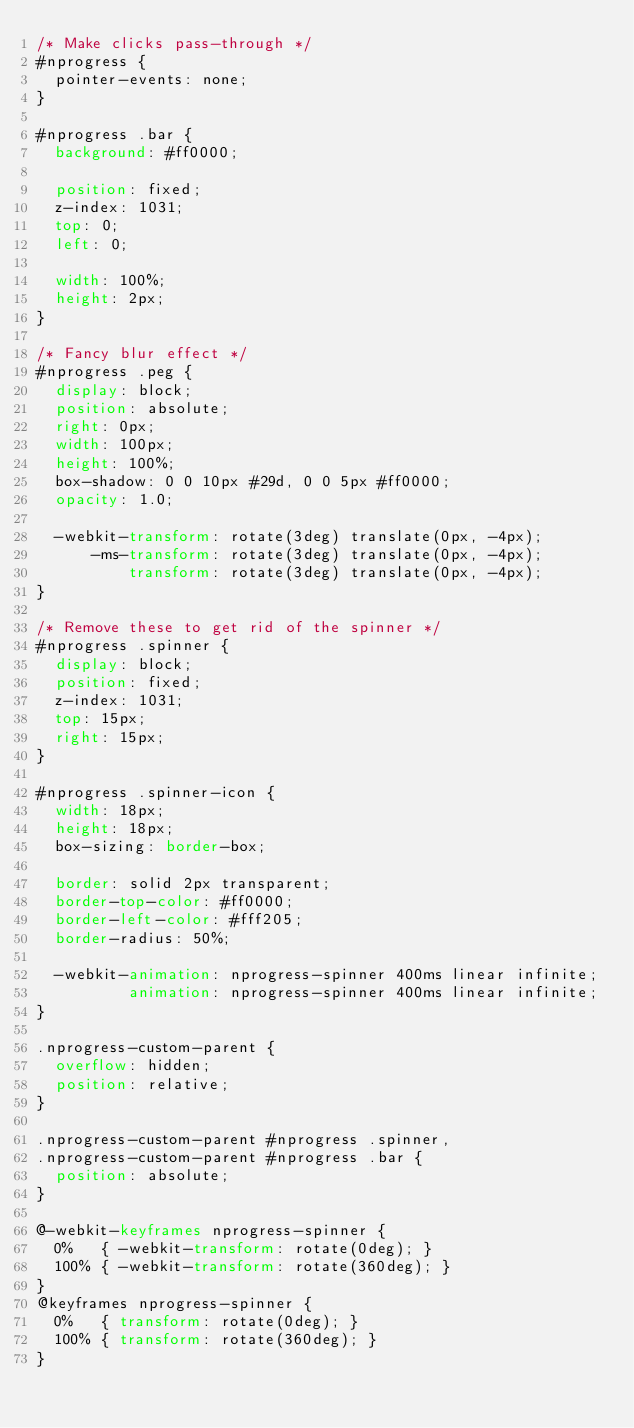Convert code to text. <code><loc_0><loc_0><loc_500><loc_500><_CSS_>/* Make clicks pass-through */
#nprogress {
  pointer-events: none;
}

#nprogress .bar {
  background: #ff0000;

  position: fixed;
  z-index: 1031;
  top: 0;
  left: 0;

  width: 100%;
  height: 2px;
}

/* Fancy blur effect */
#nprogress .peg {
  display: block;
  position: absolute;
  right: 0px;
  width: 100px;
  height: 100%;
  box-shadow: 0 0 10px #29d, 0 0 5px #ff0000;
  opacity: 1.0;

  -webkit-transform: rotate(3deg) translate(0px, -4px);
      -ms-transform: rotate(3deg) translate(0px, -4px);
          transform: rotate(3deg) translate(0px, -4px);
}

/* Remove these to get rid of the spinner */
#nprogress .spinner {
  display: block;
  position: fixed;
  z-index: 1031;
  top: 15px;
  right: 15px;
}

#nprogress .spinner-icon {
  width: 18px;
  height: 18px;
  box-sizing: border-box;

  border: solid 2px transparent;
  border-top-color: #ff0000;
  border-left-color: #fff205;
  border-radius: 50%;

  -webkit-animation: nprogress-spinner 400ms linear infinite;
          animation: nprogress-spinner 400ms linear infinite;
}

.nprogress-custom-parent {
  overflow: hidden;
  position: relative;
}

.nprogress-custom-parent #nprogress .spinner,
.nprogress-custom-parent #nprogress .bar {
  position: absolute;
}

@-webkit-keyframes nprogress-spinner {
  0%   { -webkit-transform: rotate(0deg); }
  100% { -webkit-transform: rotate(360deg); }
}
@keyframes nprogress-spinner {
  0%   { transform: rotate(0deg); }
  100% { transform: rotate(360deg); }
}

</code> 